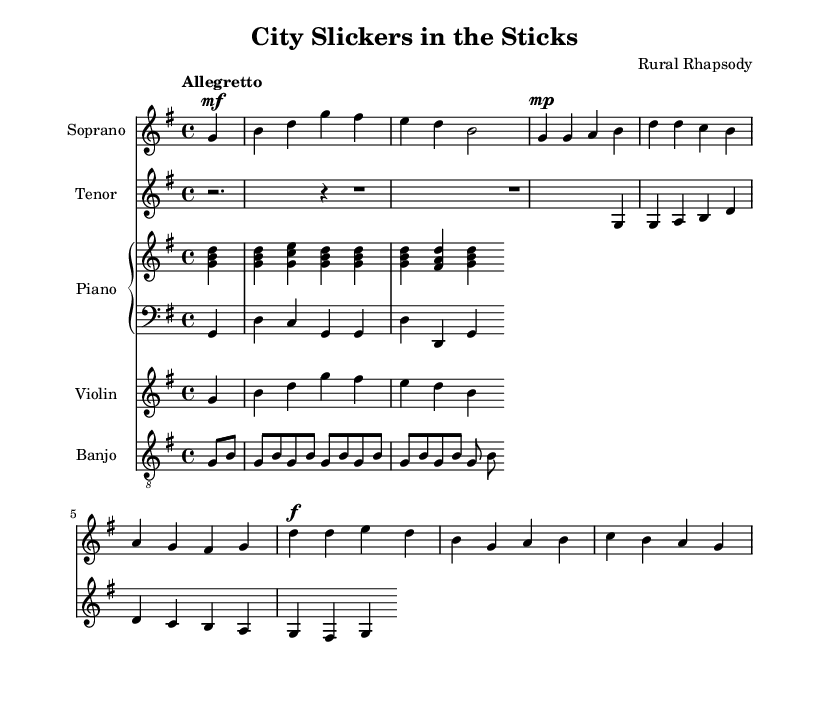What is the key signature of this music? The key signature is G major, which contains one sharp (F#). This is indicated at the beginning of the score.
Answer: G major What is the time signature of this piece? The time signature is 4/4, which is shown at the beginning of the score. This indicates that there are four beats in a measure and a quarter note receives one beat.
Answer: 4/4 What is the tempo marking for the piece? The tempo marking is "Allegretto," which instructs the performers to play at a moderately quick pace. This is specified under the global block of the score.
Answer: Allegretto How many measures does the soprano part contain? The soprano part consists of eight measures, as counted from the musical notation, separating each measure by vertical lines on the staff.
Answer: Eight What type of ensemble is being depicted in this opera? The ensemble consists of a soprano, tenor, piano (with right and left hand parts), violin, and banjo, as indicated by the separate staves for each instrument.
Answer: Mixed ensemble What is the main theme conveyed by the lyrics in verse one? The main theme conveys the contrast between the simple and clean life of country living and the lack of understanding that city folk have towards it. This can be interpreted from the lyrics provided.
Answer: Culture clash What is the function of the banjo in this piece? The banjo provides rhythmic support and adds a folk element characteristic of country music, which complements the overall theme of city versus country living. This can be inferred from its unique presence in the instrumentation list.
Answer: Rhythmic support 